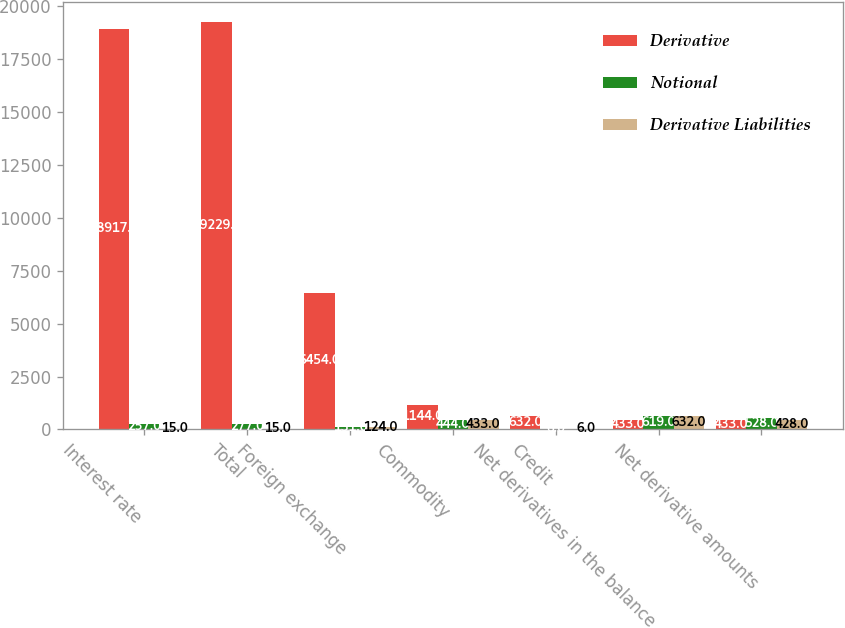<chart> <loc_0><loc_0><loc_500><loc_500><stacked_bar_chart><ecel><fcel>Interest rate<fcel>Total<fcel>Foreign exchange<fcel>Commodity<fcel>Credit<fcel>Net derivatives in the balance<fcel>Net derivative amounts<nl><fcel>Derivative<fcel>18917<fcel>19229<fcel>6454<fcel>1144<fcel>632<fcel>433<fcel>433<nl><fcel>Notional<fcel>257<fcel>277<fcel>131<fcel>444<fcel>6<fcel>619<fcel>528<nl><fcel>Derivative Liabilities<fcel>15<fcel>15<fcel>124<fcel>433<fcel>6<fcel>632<fcel>428<nl></chart> 